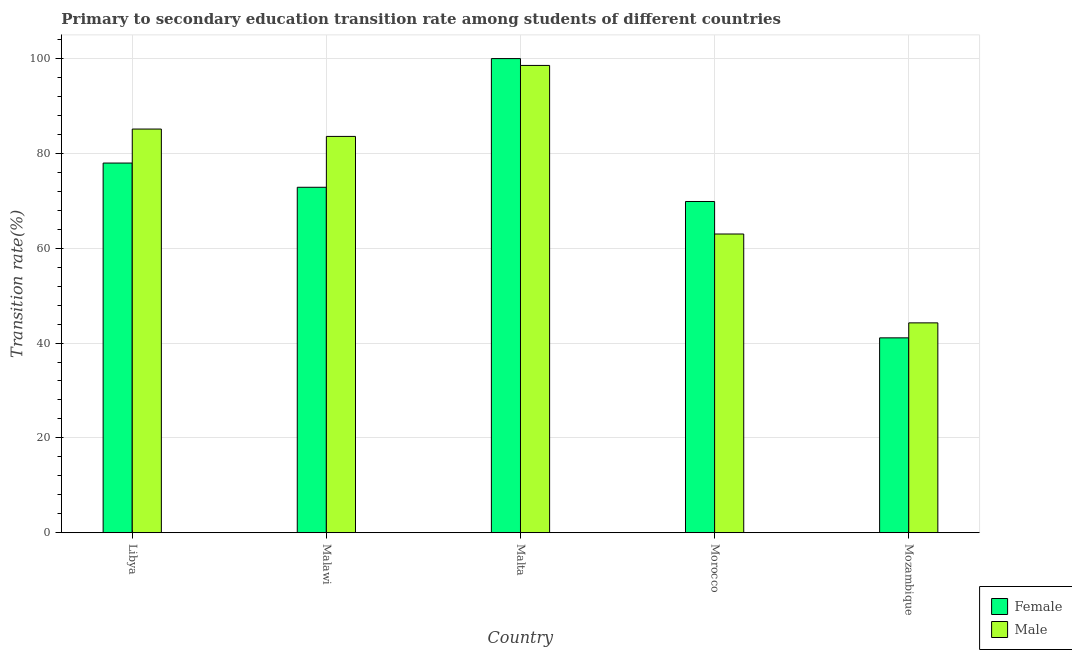Are the number of bars per tick equal to the number of legend labels?
Offer a very short reply. Yes. Are the number of bars on each tick of the X-axis equal?
Offer a very short reply. Yes. What is the label of the 2nd group of bars from the left?
Offer a terse response. Malawi. In how many cases, is the number of bars for a given country not equal to the number of legend labels?
Offer a very short reply. 0. What is the transition rate among male students in Mozambique?
Provide a succinct answer. 44.26. Across all countries, what is the maximum transition rate among male students?
Your response must be concise. 98.56. Across all countries, what is the minimum transition rate among male students?
Make the answer very short. 44.26. In which country was the transition rate among male students maximum?
Your answer should be very brief. Malta. In which country was the transition rate among male students minimum?
Keep it short and to the point. Mozambique. What is the total transition rate among female students in the graph?
Offer a terse response. 361.77. What is the difference between the transition rate among female students in Libya and that in Morocco?
Give a very brief answer. 8.11. What is the difference between the transition rate among male students in Libya and the transition rate among female students in Mozambique?
Provide a short and direct response. 44.04. What is the average transition rate among female students per country?
Make the answer very short. 72.35. What is the difference between the transition rate among female students and transition rate among male students in Morocco?
Your answer should be very brief. 6.86. What is the ratio of the transition rate among male students in Malawi to that in Mozambique?
Your answer should be compact. 1.89. What is the difference between the highest and the second highest transition rate among male students?
Your answer should be very brief. 13.42. What is the difference between the highest and the lowest transition rate among male students?
Offer a terse response. 54.3. What does the 1st bar from the left in Mozambique represents?
Offer a very short reply. Female. What does the 1st bar from the right in Malawi represents?
Provide a succinct answer. Male. How many countries are there in the graph?
Your answer should be very brief. 5. What is the difference between two consecutive major ticks on the Y-axis?
Offer a terse response. 20. Does the graph contain any zero values?
Make the answer very short. No. How many legend labels are there?
Ensure brevity in your answer.  2. How are the legend labels stacked?
Keep it short and to the point. Vertical. What is the title of the graph?
Offer a very short reply. Primary to secondary education transition rate among students of different countries. What is the label or title of the X-axis?
Offer a terse response. Country. What is the label or title of the Y-axis?
Give a very brief answer. Transition rate(%). What is the Transition rate(%) of Female in Libya?
Offer a very short reply. 77.96. What is the Transition rate(%) of Male in Libya?
Your answer should be very brief. 85.14. What is the Transition rate(%) in Female in Malawi?
Your response must be concise. 72.86. What is the Transition rate(%) in Male in Malawi?
Your response must be concise. 83.59. What is the Transition rate(%) of Male in Malta?
Make the answer very short. 98.56. What is the Transition rate(%) in Female in Morocco?
Offer a terse response. 69.86. What is the Transition rate(%) of Male in Morocco?
Your answer should be compact. 63. What is the Transition rate(%) in Female in Mozambique?
Give a very brief answer. 41.1. What is the Transition rate(%) of Male in Mozambique?
Provide a short and direct response. 44.26. Across all countries, what is the maximum Transition rate(%) in Male?
Offer a very short reply. 98.56. Across all countries, what is the minimum Transition rate(%) in Female?
Offer a terse response. 41.1. Across all countries, what is the minimum Transition rate(%) in Male?
Offer a very short reply. 44.26. What is the total Transition rate(%) of Female in the graph?
Your response must be concise. 361.77. What is the total Transition rate(%) in Male in the graph?
Your response must be concise. 374.53. What is the difference between the Transition rate(%) of Female in Libya and that in Malawi?
Ensure brevity in your answer.  5.11. What is the difference between the Transition rate(%) in Male in Libya and that in Malawi?
Ensure brevity in your answer.  1.55. What is the difference between the Transition rate(%) in Female in Libya and that in Malta?
Ensure brevity in your answer.  -22.04. What is the difference between the Transition rate(%) in Male in Libya and that in Malta?
Provide a succinct answer. -13.42. What is the difference between the Transition rate(%) in Female in Libya and that in Morocco?
Ensure brevity in your answer.  8.11. What is the difference between the Transition rate(%) of Male in Libya and that in Morocco?
Give a very brief answer. 22.14. What is the difference between the Transition rate(%) in Female in Libya and that in Mozambique?
Your response must be concise. 36.87. What is the difference between the Transition rate(%) in Male in Libya and that in Mozambique?
Your answer should be compact. 40.88. What is the difference between the Transition rate(%) in Female in Malawi and that in Malta?
Make the answer very short. -27.14. What is the difference between the Transition rate(%) in Male in Malawi and that in Malta?
Your response must be concise. -14.97. What is the difference between the Transition rate(%) of Female in Malawi and that in Morocco?
Keep it short and to the point. 3. What is the difference between the Transition rate(%) in Male in Malawi and that in Morocco?
Offer a very short reply. 20.59. What is the difference between the Transition rate(%) in Female in Malawi and that in Mozambique?
Provide a succinct answer. 31.76. What is the difference between the Transition rate(%) in Male in Malawi and that in Mozambique?
Provide a succinct answer. 39.33. What is the difference between the Transition rate(%) in Female in Malta and that in Morocco?
Make the answer very short. 30.14. What is the difference between the Transition rate(%) in Male in Malta and that in Morocco?
Give a very brief answer. 35.56. What is the difference between the Transition rate(%) in Female in Malta and that in Mozambique?
Provide a succinct answer. 58.9. What is the difference between the Transition rate(%) in Male in Malta and that in Mozambique?
Ensure brevity in your answer.  54.3. What is the difference between the Transition rate(%) in Female in Morocco and that in Mozambique?
Your answer should be compact. 28.76. What is the difference between the Transition rate(%) of Male in Morocco and that in Mozambique?
Your answer should be compact. 18.74. What is the difference between the Transition rate(%) in Female in Libya and the Transition rate(%) in Male in Malawi?
Give a very brief answer. -5.62. What is the difference between the Transition rate(%) of Female in Libya and the Transition rate(%) of Male in Malta?
Provide a short and direct response. -20.59. What is the difference between the Transition rate(%) of Female in Libya and the Transition rate(%) of Male in Morocco?
Give a very brief answer. 14.97. What is the difference between the Transition rate(%) of Female in Libya and the Transition rate(%) of Male in Mozambique?
Provide a succinct answer. 33.71. What is the difference between the Transition rate(%) in Female in Malawi and the Transition rate(%) in Male in Malta?
Provide a short and direct response. -25.7. What is the difference between the Transition rate(%) of Female in Malawi and the Transition rate(%) of Male in Morocco?
Your answer should be very brief. 9.86. What is the difference between the Transition rate(%) of Female in Malawi and the Transition rate(%) of Male in Mozambique?
Provide a short and direct response. 28.6. What is the difference between the Transition rate(%) in Female in Malta and the Transition rate(%) in Male in Morocco?
Keep it short and to the point. 37. What is the difference between the Transition rate(%) in Female in Malta and the Transition rate(%) in Male in Mozambique?
Keep it short and to the point. 55.74. What is the difference between the Transition rate(%) of Female in Morocco and the Transition rate(%) of Male in Mozambique?
Your answer should be very brief. 25.6. What is the average Transition rate(%) in Female per country?
Make the answer very short. 72.35. What is the average Transition rate(%) of Male per country?
Offer a terse response. 74.91. What is the difference between the Transition rate(%) of Female and Transition rate(%) of Male in Libya?
Offer a terse response. -7.17. What is the difference between the Transition rate(%) of Female and Transition rate(%) of Male in Malawi?
Give a very brief answer. -10.73. What is the difference between the Transition rate(%) in Female and Transition rate(%) in Male in Malta?
Provide a succinct answer. 1.44. What is the difference between the Transition rate(%) in Female and Transition rate(%) in Male in Morocco?
Ensure brevity in your answer.  6.86. What is the difference between the Transition rate(%) in Female and Transition rate(%) in Male in Mozambique?
Ensure brevity in your answer.  -3.16. What is the ratio of the Transition rate(%) in Female in Libya to that in Malawi?
Ensure brevity in your answer.  1.07. What is the ratio of the Transition rate(%) of Male in Libya to that in Malawi?
Your answer should be compact. 1.02. What is the ratio of the Transition rate(%) in Female in Libya to that in Malta?
Offer a very short reply. 0.78. What is the ratio of the Transition rate(%) in Male in Libya to that in Malta?
Provide a short and direct response. 0.86. What is the ratio of the Transition rate(%) in Female in Libya to that in Morocco?
Your answer should be very brief. 1.12. What is the ratio of the Transition rate(%) in Male in Libya to that in Morocco?
Provide a short and direct response. 1.35. What is the ratio of the Transition rate(%) in Female in Libya to that in Mozambique?
Give a very brief answer. 1.9. What is the ratio of the Transition rate(%) of Male in Libya to that in Mozambique?
Keep it short and to the point. 1.92. What is the ratio of the Transition rate(%) in Female in Malawi to that in Malta?
Ensure brevity in your answer.  0.73. What is the ratio of the Transition rate(%) of Male in Malawi to that in Malta?
Offer a terse response. 0.85. What is the ratio of the Transition rate(%) in Female in Malawi to that in Morocco?
Give a very brief answer. 1.04. What is the ratio of the Transition rate(%) in Male in Malawi to that in Morocco?
Give a very brief answer. 1.33. What is the ratio of the Transition rate(%) in Female in Malawi to that in Mozambique?
Offer a very short reply. 1.77. What is the ratio of the Transition rate(%) in Male in Malawi to that in Mozambique?
Ensure brevity in your answer.  1.89. What is the ratio of the Transition rate(%) of Female in Malta to that in Morocco?
Give a very brief answer. 1.43. What is the ratio of the Transition rate(%) of Male in Malta to that in Morocco?
Your response must be concise. 1.56. What is the ratio of the Transition rate(%) of Female in Malta to that in Mozambique?
Offer a very short reply. 2.43. What is the ratio of the Transition rate(%) in Male in Malta to that in Mozambique?
Your response must be concise. 2.23. What is the ratio of the Transition rate(%) in Female in Morocco to that in Mozambique?
Give a very brief answer. 1.7. What is the ratio of the Transition rate(%) in Male in Morocco to that in Mozambique?
Ensure brevity in your answer.  1.42. What is the difference between the highest and the second highest Transition rate(%) in Female?
Offer a very short reply. 22.04. What is the difference between the highest and the second highest Transition rate(%) of Male?
Your answer should be compact. 13.42. What is the difference between the highest and the lowest Transition rate(%) of Female?
Offer a very short reply. 58.9. What is the difference between the highest and the lowest Transition rate(%) in Male?
Offer a very short reply. 54.3. 